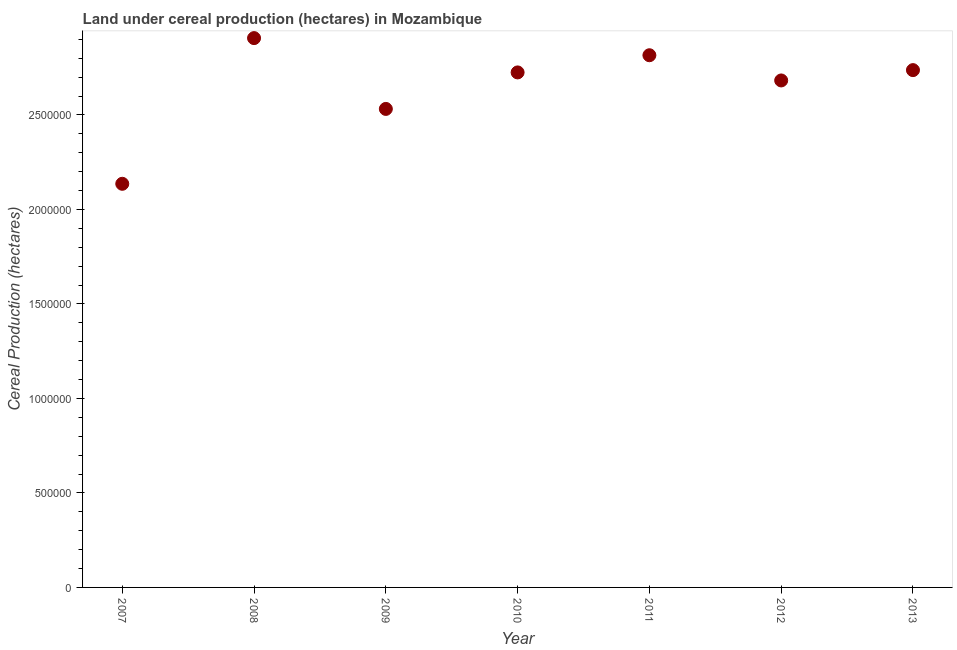What is the land under cereal production in 2011?
Provide a succinct answer. 2.82e+06. Across all years, what is the maximum land under cereal production?
Give a very brief answer. 2.91e+06. Across all years, what is the minimum land under cereal production?
Your answer should be compact. 2.14e+06. In which year was the land under cereal production maximum?
Offer a terse response. 2008. What is the sum of the land under cereal production?
Offer a terse response. 1.85e+07. What is the difference between the land under cereal production in 2009 and 2011?
Provide a succinct answer. -2.84e+05. What is the average land under cereal production per year?
Your answer should be compact. 2.65e+06. What is the median land under cereal production?
Offer a very short reply. 2.73e+06. In how many years, is the land under cereal production greater than 1500000 hectares?
Provide a succinct answer. 7. Do a majority of the years between 2009 and 2007 (inclusive) have land under cereal production greater than 2200000 hectares?
Provide a succinct answer. No. What is the ratio of the land under cereal production in 2008 to that in 2013?
Keep it short and to the point. 1.06. Is the land under cereal production in 2008 less than that in 2013?
Make the answer very short. No. What is the difference between the highest and the second highest land under cereal production?
Your answer should be very brief. 9.06e+04. What is the difference between the highest and the lowest land under cereal production?
Make the answer very short. 7.71e+05. In how many years, is the land under cereal production greater than the average land under cereal production taken over all years?
Keep it short and to the point. 5. How many dotlines are there?
Your answer should be compact. 1. How many years are there in the graph?
Make the answer very short. 7. What is the difference between two consecutive major ticks on the Y-axis?
Your answer should be very brief. 5.00e+05. Are the values on the major ticks of Y-axis written in scientific E-notation?
Make the answer very short. No. Does the graph contain any zero values?
Give a very brief answer. No. What is the title of the graph?
Provide a short and direct response. Land under cereal production (hectares) in Mozambique. What is the label or title of the Y-axis?
Ensure brevity in your answer.  Cereal Production (hectares). What is the Cereal Production (hectares) in 2007?
Make the answer very short. 2.14e+06. What is the Cereal Production (hectares) in 2008?
Keep it short and to the point. 2.91e+06. What is the Cereal Production (hectares) in 2009?
Make the answer very short. 2.53e+06. What is the Cereal Production (hectares) in 2010?
Offer a terse response. 2.73e+06. What is the Cereal Production (hectares) in 2011?
Ensure brevity in your answer.  2.82e+06. What is the Cereal Production (hectares) in 2012?
Offer a very short reply. 2.68e+06. What is the Cereal Production (hectares) in 2013?
Keep it short and to the point. 2.74e+06. What is the difference between the Cereal Production (hectares) in 2007 and 2008?
Offer a very short reply. -7.71e+05. What is the difference between the Cereal Production (hectares) in 2007 and 2009?
Provide a short and direct response. -3.96e+05. What is the difference between the Cereal Production (hectares) in 2007 and 2010?
Provide a succinct answer. -5.89e+05. What is the difference between the Cereal Production (hectares) in 2007 and 2011?
Ensure brevity in your answer.  -6.80e+05. What is the difference between the Cereal Production (hectares) in 2007 and 2012?
Give a very brief answer. -5.47e+05. What is the difference between the Cereal Production (hectares) in 2007 and 2013?
Your response must be concise. -6.02e+05. What is the difference between the Cereal Production (hectares) in 2008 and 2009?
Offer a very short reply. 3.75e+05. What is the difference between the Cereal Production (hectares) in 2008 and 2010?
Keep it short and to the point. 1.82e+05. What is the difference between the Cereal Production (hectares) in 2008 and 2011?
Your answer should be very brief. 9.06e+04. What is the difference between the Cereal Production (hectares) in 2008 and 2012?
Offer a very short reply. 2.24e+05. What is the difference between the Cereal Production (hectares) in 2008 and 2013?
Your answer should be compact. 1.69e+05. What is the difference between the Cereal Production (hectares) in 2009 and 2010?
Offer a terse response. -1.93e+05. What is the difference between the Cereal Production (hectares) in 2009 and 2011?
Ensure brevity in your answer.  -2.84e+05. What is the difference between the Cereal Production (hectares) in 2009 and 2012?
Keep it short and to the point. -1.51e+05. What is the difference between the Cereal Production (hectares) in 2009 and 2013?
Provide a succinct answer. -2.05e+05. What is the difference between the Cereal Production (hectares) in 2010 and 2011?
Provide a succinct answer. -9.09e+04. What is the difference between the Cereal Production (hectares) in 2010 and 2012?
Make the answer very short. 4.25e+04. What is the difference between the Cereal Production (hectares) in 2010 and 2013?
Make the answer very short. -1.22e+04. What is the difference between the Cereal Production (hectares) in 2011 and 2012?
Your answer should be very brief. 1.33e+05. What is the difference between the Cereal Production (hectares) in 2011 and 2013?
Make the answer very short. 7.88e+04. What is the difference between the Cereal Production (hectares) in 2012 and 2013?
Give a very brief answer. -5.46e+04. What is the ratio of the Cereal Production (hectares) in 2007 to that in 2008?
Offer a terse response. 0.73. What is the ratio of the Cereal Production (hectares) in 2007 to that in 2009?
Your answer should be very brief. 0.84. What is the ratio of the Cereal Production (hectares) in 2007 to that in 2010?
Make the answer very short. 0.78. What is the ratio of the Cereal Production (hectares) in 2007 to that in 2011?
Provide a short and direct response. 0.76. What is the ratio of the Cereal Production (hectares) in 2007 to that in 2012?
Keep it short and to the point. 0.8. What is the ratio of the Cereal Production (hectares) in 2007 to that in 2013?
Offer a very short reply. 0.78. What is the ratio of the Cereal Production (hectares) in 2008 to that in 2009?
Keep it short and to the point. 1.15. What is the ratio of the Cereal Production (hectares) in 2008 to that in 2010?
Make the answer very short. 1.07. What is the ratio of the Cereal Production (hectares) in 2008 to that in 2011?
Offer a very short reply. 1.03. What is the ratio of the Cereal Production (hectares) in 2008 to that in 2012?
Your answer should be compact. 1.08. What is the ratio of the Cereal Production (hectares) in 2008 to that in 2013?
Give a very brief answer. 1.06. What is the ratio of the Cereal Production (hectares) in 2009 to that in 2010?
Keep it short and to the point. 0.93. What is the ratio of the Cereal Production (hectares) in 2009 to that in 2011?
Give a very brief answer. 0.9. What is the ratio of the Cereal Production (hectares) in 2009 to that in 2012?
Make the answer very short. 0.94. What is the ratio of the Cereal Production (hectares) in 2009 to that in 2013?
Offer a terse response. 0.93. What is the ratio of the Cereal Production (hectares) in 2010 to that in 2011?
Provide a short and direct response. 0.97. What is the ratio of the Cereal Production (hectares) in 2011 to that in 2012?
Your response must be concise. 1.05. What is the ratio of the Cereal Production (hectares) in 2012 to that in 2013?
Provide a short and direct response. 0.98. 